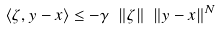<formula> <loc_0><loc_0><loc_500><loc_500>\langle \zeta , y - x \rangle \leq - \gamma \ \| \zeta \| \ \| y - x \| ^ { N }</formula> 